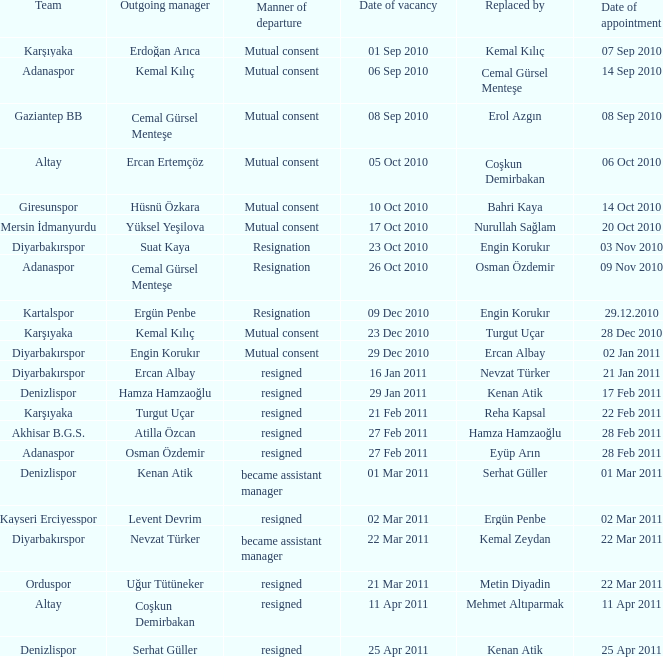Which team replaced their manager with Serhat Güller? Denizlispor. 